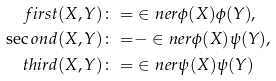<formula> <loc_0><loc_0><loc_500><loc_500>\ f i r s t ( X , Y ) \colon = & \in n e r { \phi ( X ) } { \phi ( Y ) } , \\ \sec o n d ( X , Y ) \colon = & - \in n e r { \phi ( X ) } { \psi ( Y ) } , \\ \ t h i r d ( X , Y ) \colon = & \in n e r { \psi ( X ) } { \psi ( Y ) }</formula> 